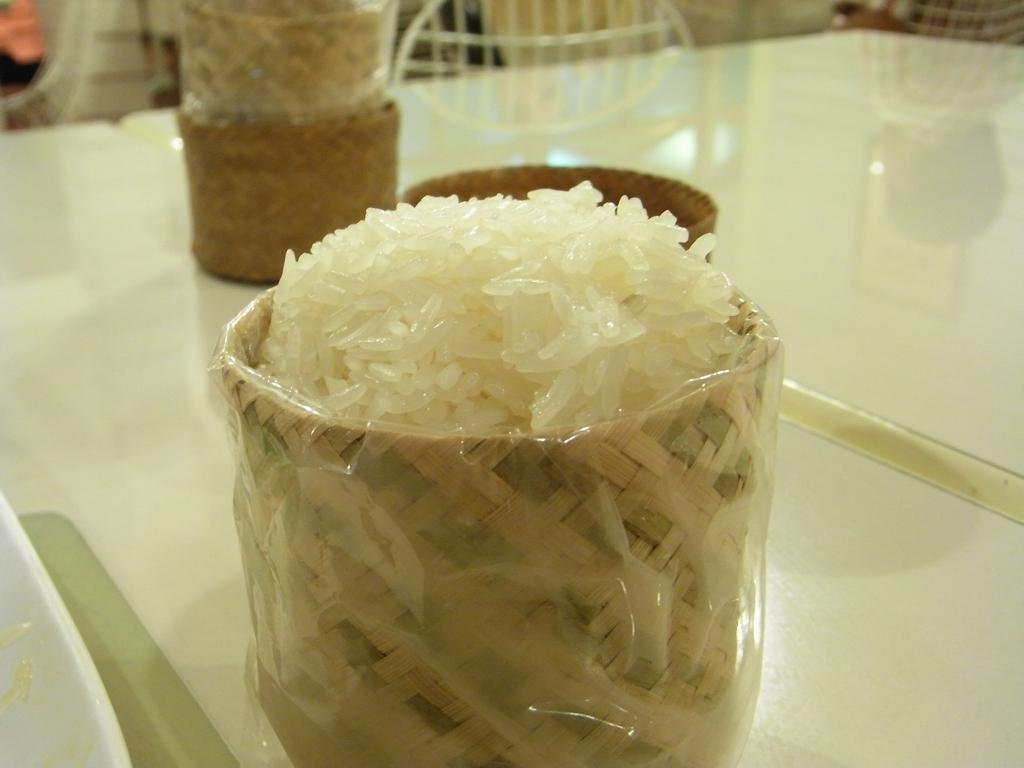What objects are present in the image? There are bowls in the image. What is inside the bowls? The bowls contain rice. How is the rice protected or covered? The rice is wrapped in polythene covers. Where are the bowls located? The bowls are placed on a table. What type of current is flowing through the rice in the image? There is no current flowing through the rice in the image; it is not an electrical or water current. 